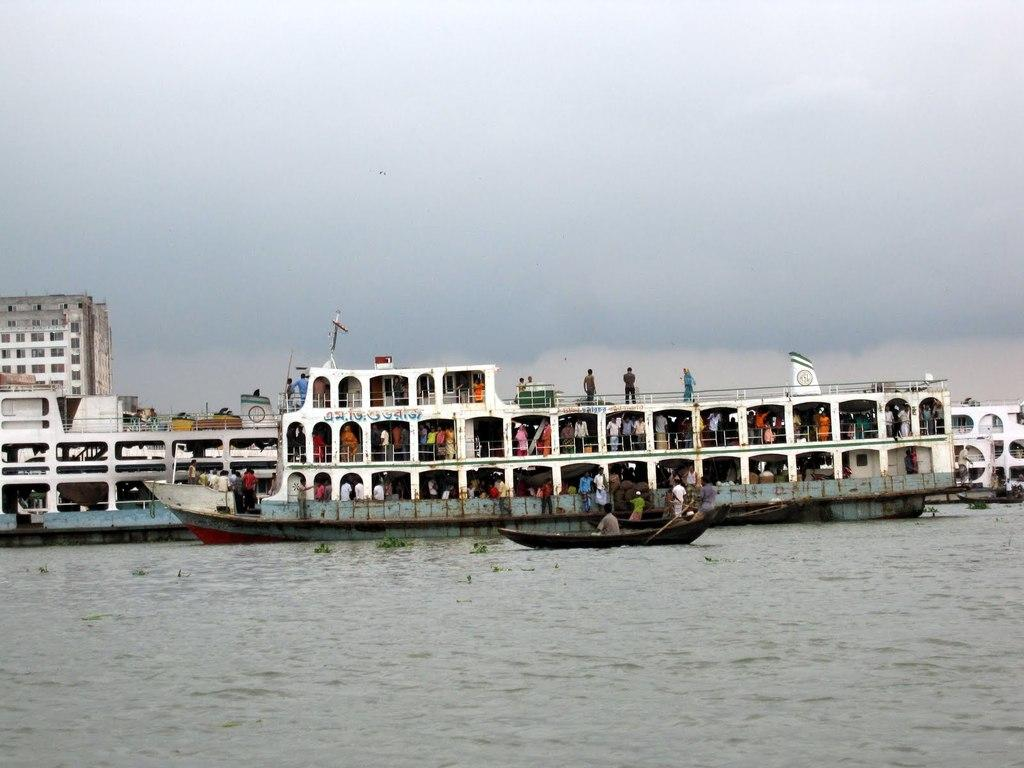What is the main subject of the image? The main subject of the image is a ship. Where is the ship located? The ship is on the water. Are there any people on the ship? Yes, there is a group of people standing in the ship. What can be seen in the background of the image? There is a building in the background of the image. What color is the building? The building is white. What is the color of the sky in the image? The sky is white in the image. What type of haircut is the ship getting in the image? There is no haircut present in the image, as the subject is a ship on the water. 